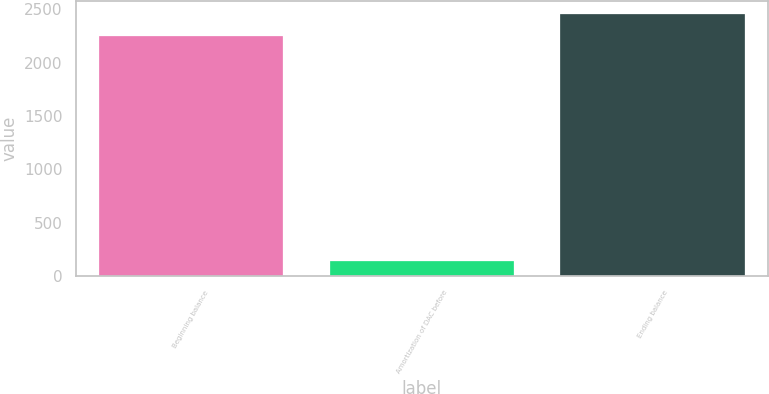Convert chart. <chart><loc_0><loc_0><loc_500><loc_500><bar_chart><fcel>Beginning balance<fcel>Amortization of DAC before<fcel>Ending balance<nl><fcel>2246<fcel>140<fcel>2458.5<nl></chart> 